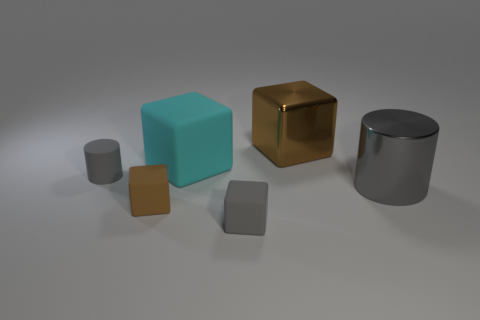Subtract 1 blocks. How many blocks are left? 3 Add 2 big cylinders. How many objects exist? 8 Subtract all cubes. How many objects are left? 2 Add 1 tiny gray matte objects. How many tiny gray matte objects are left? 3 Add 5 big blocks. How many big blocks exist? 7 Subtract 1 gray cubes. How many objects are left? 5 Subtract all large cyan blocks. Subtract all shiny things. How many objects are left? 3 